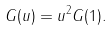Convert formula to latex. <formula><loc_0><loc_0><loc_500><loc_500>G ( u ) = u ^ { 2 } G ( 1 ) .</formula> 